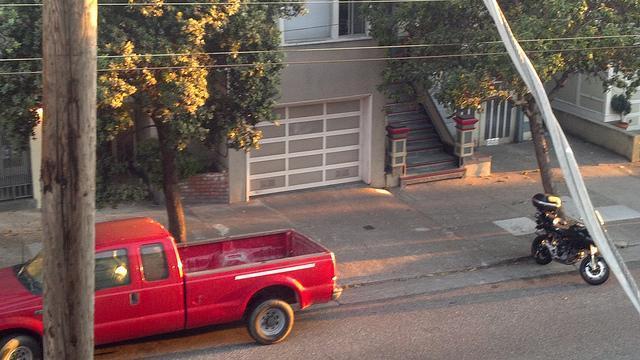How many trains are shown?
Give a very brief answer. 0. 